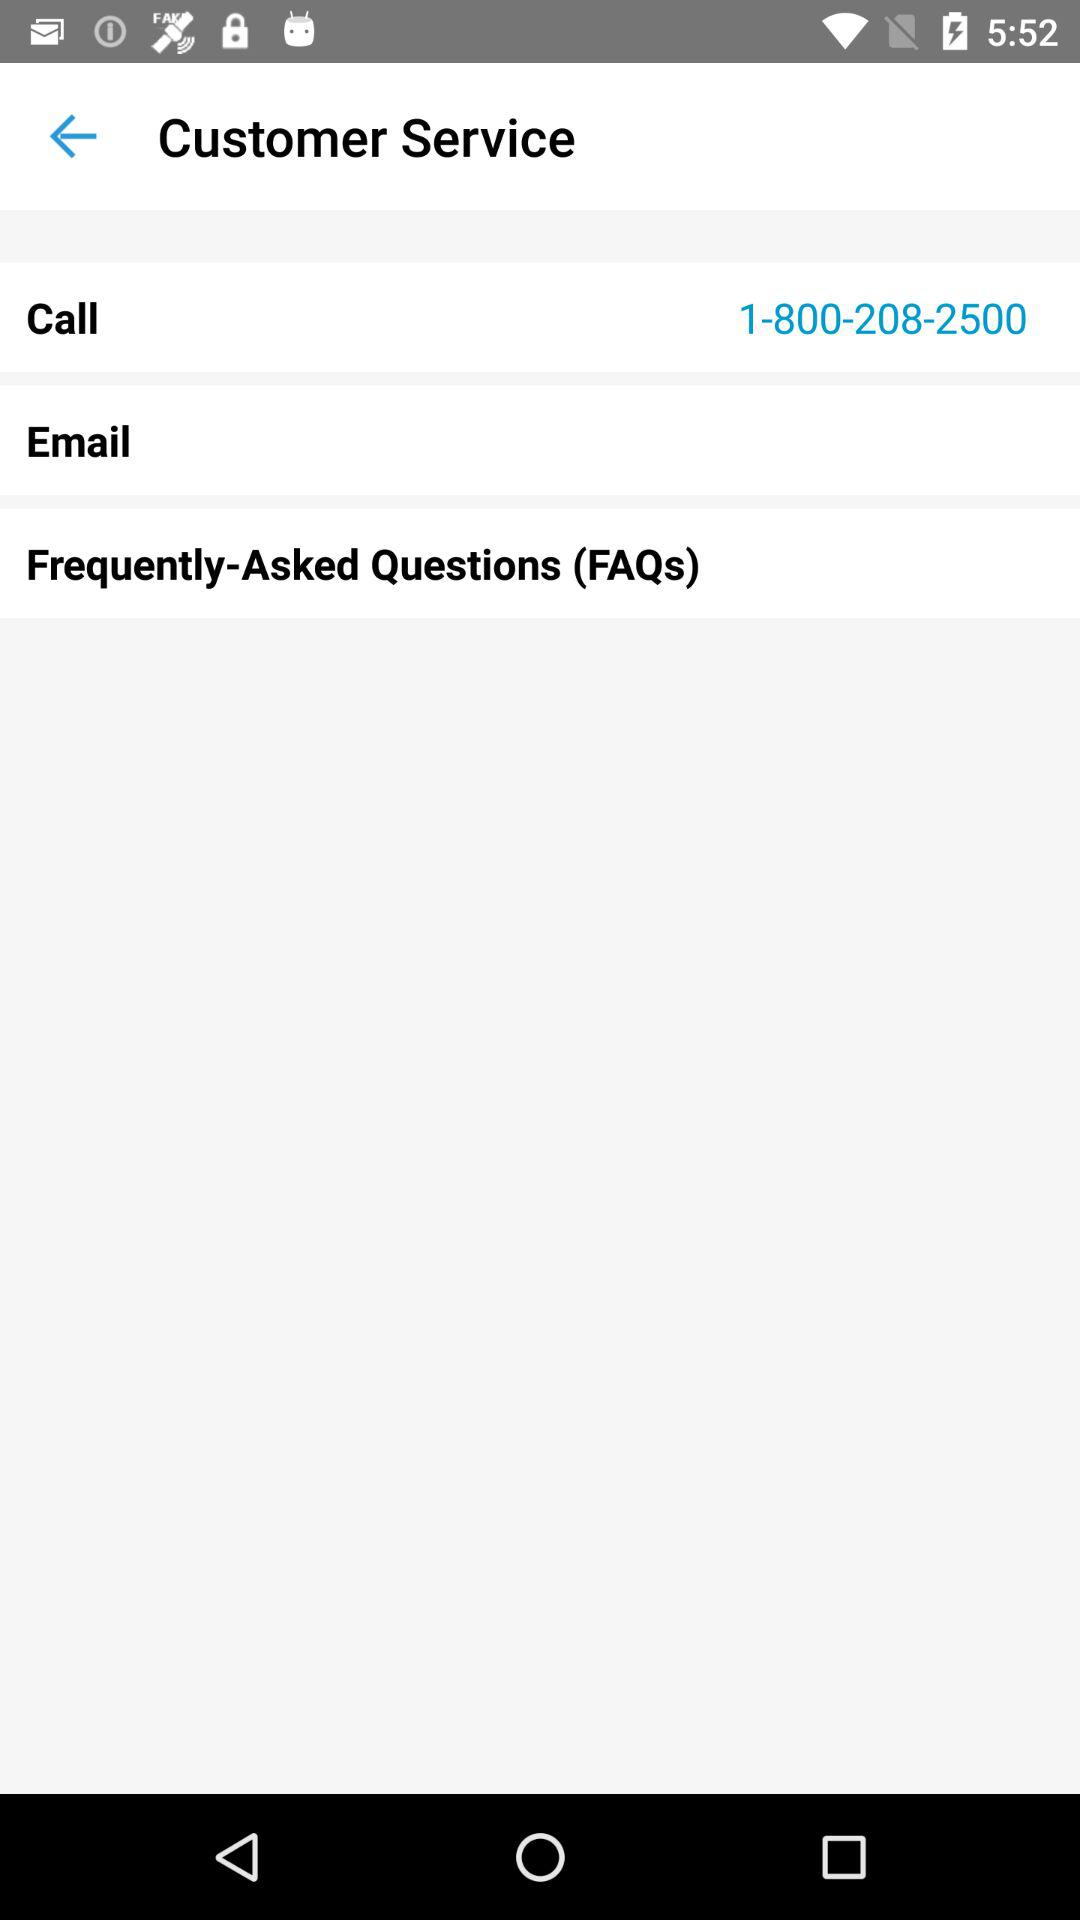What number to call? The number to call is 1-800-208-2500. 